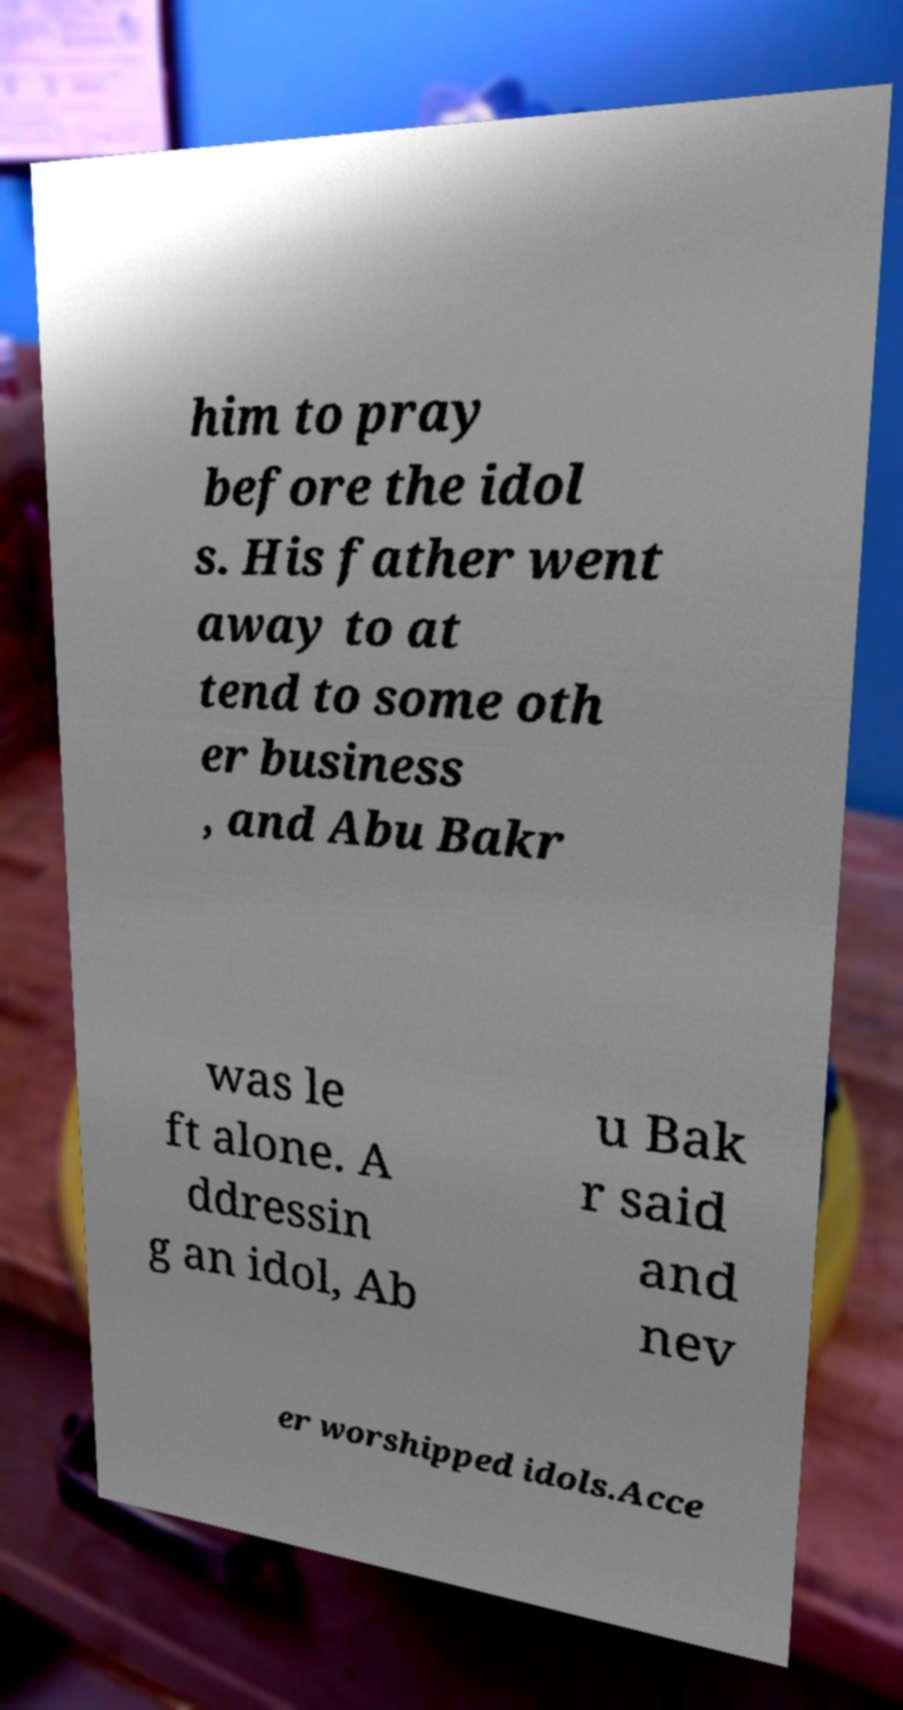Please identify and transcribe the text found in this image. him to pray before the idol s. His father went away to at tend to some oth er business , and Abu Bakr was le ft alone. A ddressin g an idol, Ab u Bak r said and nev er worshipped idols.Acce 